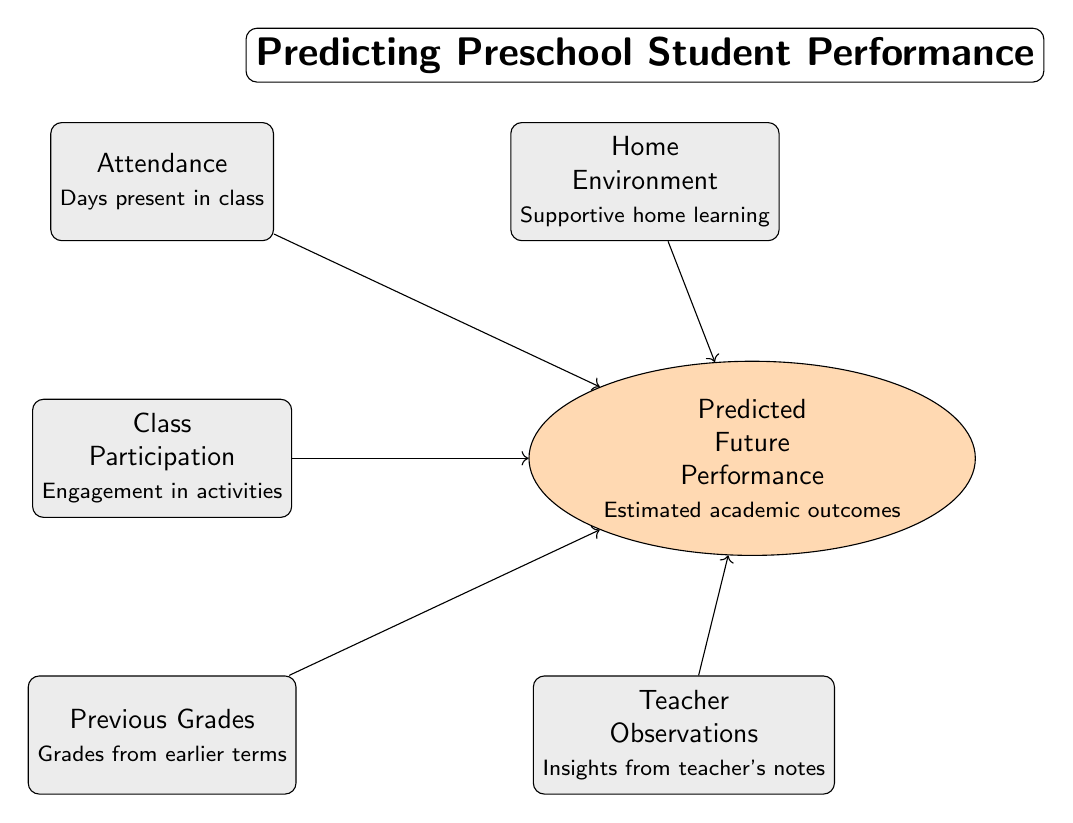What's the main goal of this diagram? The main goal is to predict future academic performance of preschool students based on various influencing factors.
Answer: Predicting future performance How many feature nodes are present in the diagram? There are five feature nodes: Attendance, Class Participation, Previous Grades, Home Environment, and Teacher Observations.
Answer: Five What does Attendance influence according to the diagram? Attendance influences the Predicted Future Performance, as indicated by the directed edge connecting the two nodes.
Answer: Predicted Future Performance What type of relationship exists between Previous Grades and Predicted Future Performance? The relationship is correlational, as shown by the edge labeled "Correlates with."
Answer: Correlates with Which feature has a supportive home aspect connected to future performance? The feature that has this aspect is Home Environment.
Answer: Home Environment How many total nodes are there in the diagram? There are six nodes in total, including both feature and target nodes.
Answer: Six What type of diagram is this? This is a Machine Learning Diagram focused on predicting student performance based on various features.
Answer: Machine Learning Diagram Which of the following features is directly connected to future performance via an edge labeled "Impacts"? The feature that is directly connected via that edge is Teacher Observations.
Answer: Teacher Observations What influences future performance the most according to the overall structure of the diagram? The overall structure suggests that all features collectively influence future performance, but none is singled out as the most significant in this specific visualization.
Answer: All features collectively 